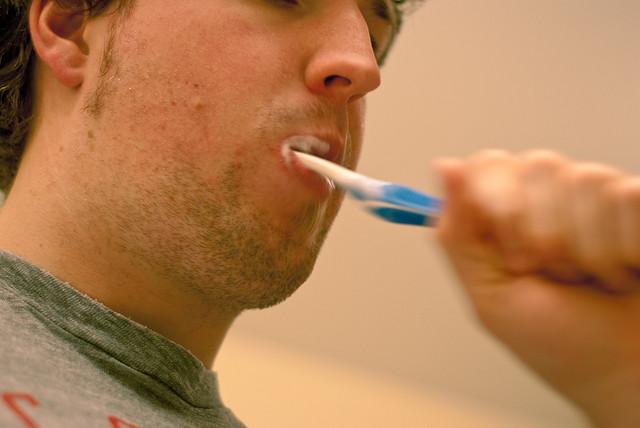Do you see toothpaste on his lips?
Keep it brief. Yes. What is the person holding?
Give a very brief answer. Toothbrush. What color is the lettering on the shirt?
Write a very short answer. Red. 